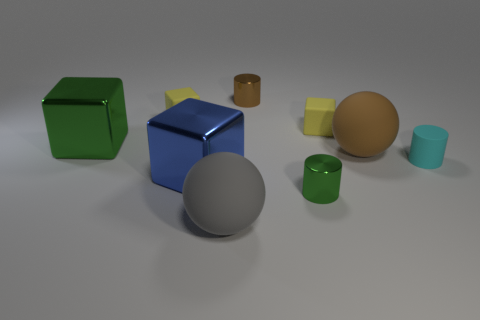What is the color of the other big thing that is made of the same material as the large blue thing?
Give a very brief answer. Green. There is a metal cylinder behind the small cyan matte thing; how big is it?
Your answer should be compact. Small. Is the number of matte cylinders that are on the left side of the large blue metal object less than the number of gray objects?
Your answer should be compact. Yes. Are there fewer tiny metallic objects than large green objects?
Your response must be concise. No. There is a rubber thing left of the sphere that is to the left of the brown matte sphere; what is its color?
Offer a very short reply. Yellow. There is a cylinder on the left side of the green object to the right of the blue cube that is in front of the brown rubber ball; what is it made of?
Provide a succinct answer. Metal. There is a green metallic thing that is behind the cyan rubber object; does it have the same size as the big brown sphere?
Provide a succinct answer. Yes. There is a big cube that is left of the large blue metal block; what is its material?
Provide a succinct answer. Metal. Is the number of yellow rubber things greater than the number of cyan objects?
Provide a short and direct response. Yes. How many objects are rubber balls that are in front of the big blue object or big blue blocks?
Your answer should be very brief. 2. 